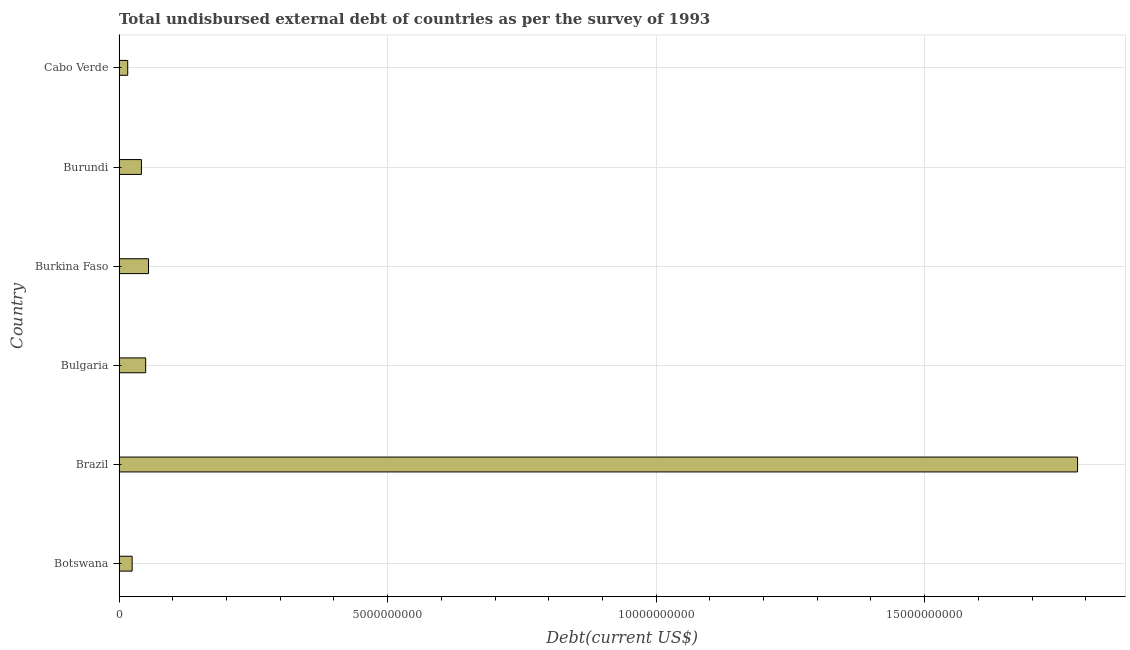Does the graph contain grids?
Offer a terse response. Yes. What is the title of the graph?
Provide a succinct answer. Total undisbursed external debt of countries as per the survey of 1993. What is the label or title of the X-axis?
Give a very brief answer. Debt(current US$). What is the total debt in Burundi?
Make the answer very short. 4.17e+08. Across all countries, what is the maximum total debt?
Provide a succinct answer. 1.78e+1. Across all countries, what is the minimum total debt?
Give a very brief answer. 1.61e+08. In which country was the total debt minimum?
Your answer should be very brief. Cabo Verde. What is the sum of the total debt?
Offer a very short reply. 1.97e+1. What is the difference between the total debt in Botswana and Bulgaria?
Your answer should be very brief. -2.52e+08. What is the average total debt per country?
Your answer should be compact. 3.29e+09. What is the median total debt?
Keep it short and to the point. 4.56e+08. What is the ratio of the total debt in Botswana to that in Bulgaria?
Provide a succinct answer. 0.49. Is the difference between the total debt in Bulgaria and Burundi greater than the difference between any two countries?
Offer a very short reply. No. What is the difference between the highest and the second highest total debt?
Your answer should be very brief. 1.73e+1. Is the sum of the total debt in Burkina Faso and Burundi greater than the maximum total debt across all countries?
Your answer should be very brief. No. What is the difference between the highest and the lowest total debt?
Provide a succinct answer. 1.77e+1. In how many countries, is the total debt greater than the average total debt taken over all countries?
Your response must be concise. 1. How many bars are there?
Your answer should be very brief. 6. How many countries are there in the graph?
Ensure brevity in your answer.  6. What is the Debt(current US$) of Botswana?
Your response must be concise. 2.44e+08. What is the Debt(current US$) of Brazil?
Provide a succinct answer. 1.78e+1. What is the Debt(current US$) in Bulgaria?
Give a very brief answer. 4.96e+08. What is the Debt(current US$) of Burkina Faso?
Give a very brief answer. 5.49e+08. What is the Debt(current US$) in Burundi?
Make the answer very short. 4.17e+08. What is the Debt(current US$) of Cabo Verde?
Offer a very short reply. 1.61e+08. What is the difference between the Debt(current US$) in Botswana and Brazil?
Your answer should be very brief. -1.76e+1. What is the difference between the Debt(current US$) in Botswana and Bulgaria?
Keep it short and to the point. -2.52e+08. What is the difference between the Debt(current US$) in Botswana and Burkina Faso?
Keep it short and to the point. -3.05e+08. What is the difference between the Debt(current US$) in Botswana and Burundi?
Give a very brief answer. -1.73e+08. What is the difference between the Debt(current US$) in Botswana and Cabo Verde?
Keep it short and to the point. 8.23e+07. What is the difference between the Debt(current US$) in Brazil and Bulgaria?
Your answer should be very brief. 1.74e+1. What is the difference between the Debt(current US$) in Brazil and Burkina Faso?
Give a very brief answer. 1.73e+1. What is the difference between the Debt(current US$) in Brazil and Burundi?
Provide a short and direct response. 1.74e+1. What is the difference between the Debt(current US$) in Brazil and Cabo Verde?
Your answer should be very brief. 1.77e+1. What is the difference between the Debt(current US$) in Bulgaria and Burkina Faso?
Give a very brief answer. -5.33e+07. What is the difference between the Debt(current US$) in Bulgaria and Burundi?
Make the answer very short. 7.88e+07. What is the difference between the Debt(current US$) in Bulgaria and Cabo Verde?
Your answer should be very brief. 3.34e+08. What is the difference between the Debt(current US$) in Burkina Faso and Burundi?
Your answer should be very brief. 1.32e+08. What is the difference between the Debt(current US$) in Burkina Faso and Cabo Verde?
Offer a very short reply. 3.88e+08. What is the difference between the Debt(current US$) in Burundi and Cabo Verde?
Ensure brevity in your answer.  2.56e+08. What is the ratio of the Debt(current US$) in Botswana to that in Brazil?
Offer a very short reply. 0.01. What is the ratio of the Debt(current US$) in Botswana to that in Bulgaria?
Ensure brevity in your answer.  0.49. What is the ratio of the Debt(current US$) in Botswana to that in Burkina Faso?
Your answer should be compact. 0.44. What is the ratio of the Debt(current US$) in Botswana to that in Burundi?
Ensure brevity in your answer.  0.58. What is the ratio of the Debt(current US$) in Botswana to that in Cabo Verde?
Keep it short and to the point. 1.51. What is the ratio of the Debt(current US$) in Brazil to that in Bulgaria?
Your answer should be compact. 36.01. What is the ratio of the Debt(current US$) in Brazil to that in Burkina Faso?
Your answer should be compact. 32.51. What is the ratio of the Debt(current US$) in Brazil to that in Burundi?
Keep it short and to the point. 42.82. What is the ratio of the Debt(current US$) in Brazil to that in Cabo Verde?
Offer a very short reply. 110.66. What is the ratio of the Debt(current US$) in Bulgaria to that in Burkina Faso?
Ensure brevity in your answer.  0.9. What is the ratio of the Debt(current US$) in Bulgaria to that in Burundi?
Your answer should be compact. 1.19. What is the ratio of the Debt(current US$) in Bulgaria to that in Cabo Verde?
Your response must be concise. 3.07. What is the ratio of the Debt(current US$) in Burkina Faso to that in Burundi?
Make the answer very short. 1.32. What is the ratio of the Debt(current US$) in Burkina Faso to that in Cabo Verde?
Your response must be concise. 3.4. What is the ratio of the Debt(current US$) in Burundi to that in Cabo Verde?
Provide a succinct answer. 2.58. 